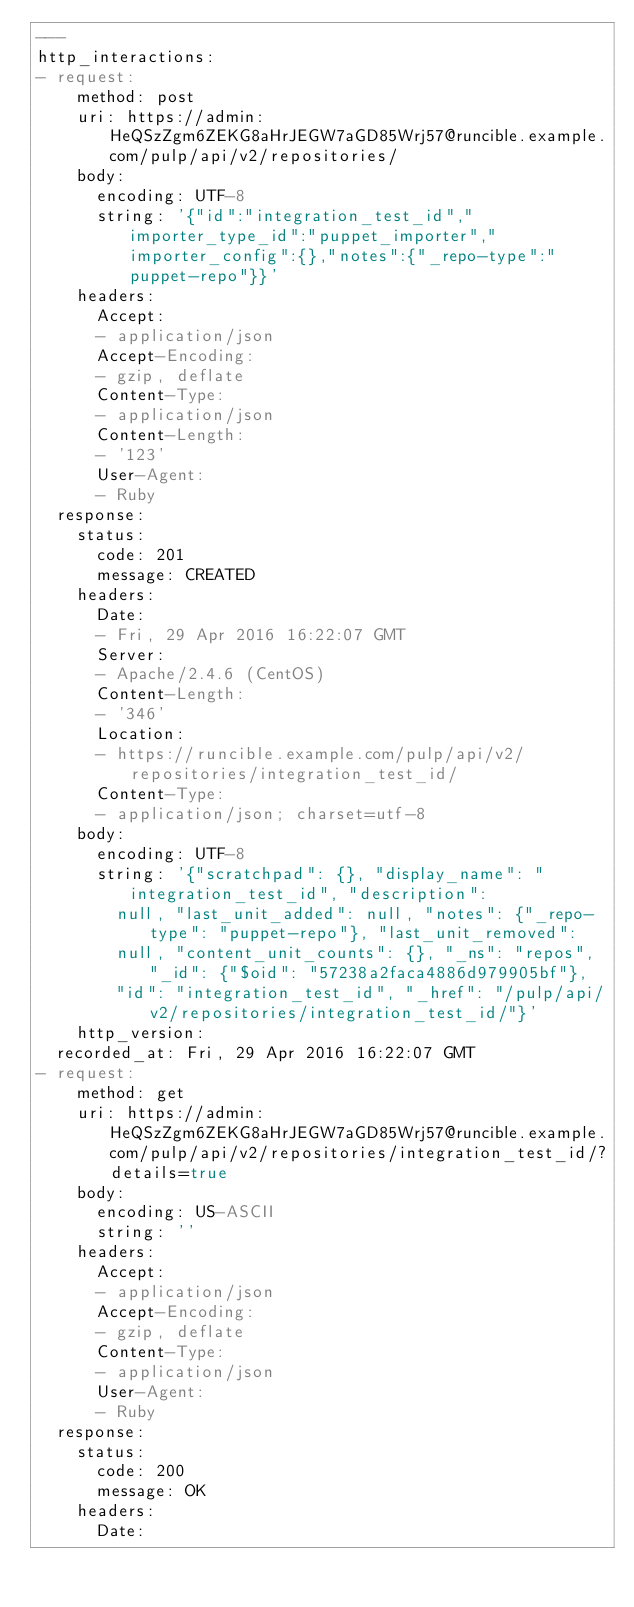Convert code to text. <code><loc_0><loc_0><loc_500><loc_500><_YAML_>---
http_interactions:
- request:
    method: post
    uri: https://admin:HeQSzZgm6ZEKG8aHrJEGW7aGD85Wrj57@runcible.example.com/pulp/api/v2/repositories/
    body:
      encoding: UTF-8
      string: '{"id":"integration_test_id","importer_type_id":"puppet_importer","importer_config":{},"notes":{"_repo-type":"puppet-repo"}}'
    headers:
      Accept:
      - application/json
      Accept-Encoding:
      - gzip, deflate
      Content-Type:
      - application/json
      Content-Length:
      - '123'
      User-Agent:
      - Ruby
  response:
    status:
      code: 201
      message: CREATED
    headers:
      Date:
      - Fri, 29 Apr 2016 16:22:07 GMT
      Server:
      - Apache/2.4.6 (CentOS)
      Content-Length:
      - '346'
      Location:
      - https://runcible.example.com/pulp/api/v2/repositories/integration_test_id/
      Content-Type:
      - application/json; charset=utf-8
    body:
      encoding: UTF-8
      string: '{"scratchpad": {}, "display_name": "integration_test_id", "description":
        null, "last_unit_added": null, "notes": {"_repo-type": "puppet-repo"}, "last_unit_removed":
        null, "content_unit_counts": {}, "_ns": "repos", "_id": {"$oid": "57238a2faca4886d979905bf"},
        "id": "integration_test_id", "_href": "/pulp/api/v2/repositories/integration_test_id/"}'
    http_version: 
  recorded_at: Fri, 29 Apr 2016 16:22:07 GMT
- request:
    method: get
    uri: https://admin:HeQSzZgm6ZEKG8aHrJEGW7aGD85Wrj57@runcible.example.com/pulp/api/v2/repositories/integration_test_id/?details=true
    body:
      encoding: US-ASCII
      string: ''
    headers:
      Accept:
      - application/json
      Accept-Encoding:
      - gzip, deflate
      Content-Type:
      - application/json
      User-Agent:
      - Ruby
  response:
    status:
      code: 200
      message: OK
    headers:
      Date:</code> 